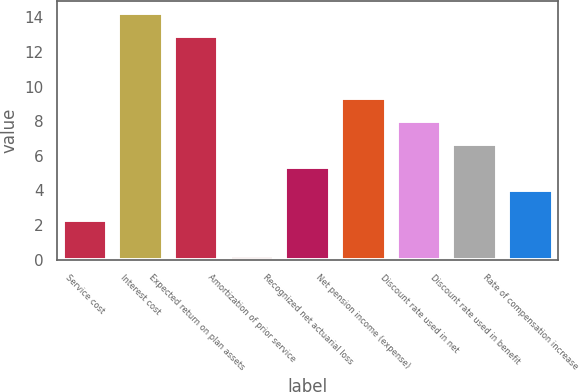Convert chart to OTSL. <chart><loc_0><loc_0><loc_500><loc_500><bar_chart><fcel>Service cost<fcel>Interest cost<fcel>Expected return on plan assets<fcel>Amortization of prior service<fcel>Recognized net actuarial loss<fcel>Net pension income (expense)<fcel>Discount rate used in net<fcel>Discount rate used in benefit<fcel>Rate of compensation increase<nl><fcel>2.3<fcel>14.23<fcel>12.9<fcel>0.2<fcel>5.33<fcel>9.32<fcel>7.99<fcel>6.66<fcel>4<nl></chart> 